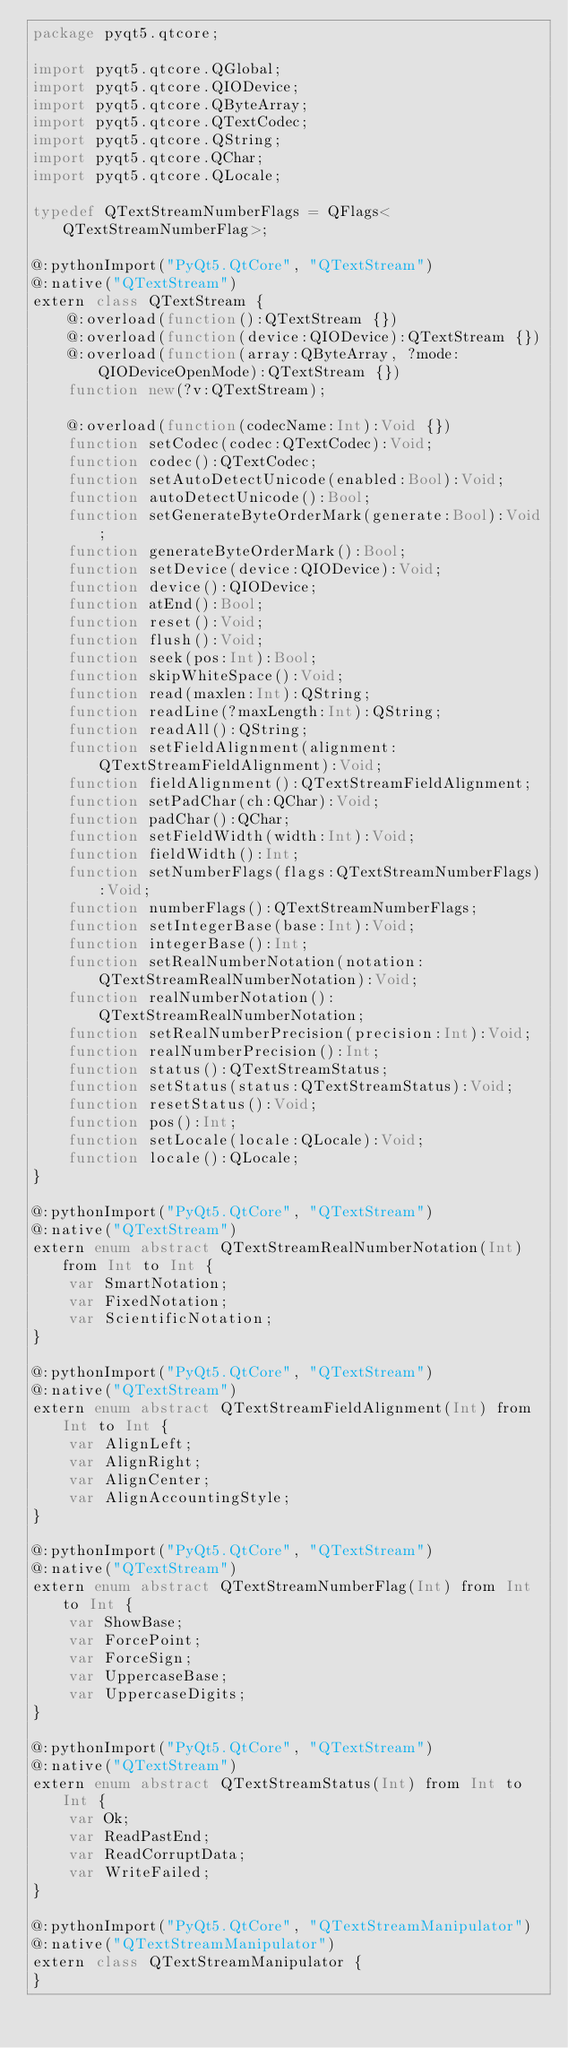<code> <loc_0><loc_0><loc_500><loc_500><_Haxe_>package pyqt5.qtcore;

import pyqt5.qtcore.QGlobal;
import pyqt5.qtcore.QIODevice;
import pyqt5.qtcore.QByteArray;
import pyqt5.qtcore.QTextCodec;
import pyqt5.qtcore.QString;
import pyqt5.qtcore.QChar;
import pyqt5.qtcore.QLocale;

typedef QTextStreamNumberFlags = QFlags<QTextStreamNumberFlag>;

@:pythonImport("PyQt5.QtCore", "QTextStream")
@:native("QTextStream")
extern class QTextStream {
	@:overload(function():QTextStream {})
	@:overload(function(device:QIODevice):QTextStream {})
	@:overload(function(array:QByteArray, ?mode:QIODeviceOpenMode):QTextStream {})
	function new(?v:QTextStream);

	@:overload(function(codecName:Int):Void {})
	function setCodec(codec:QTextCodec):Void;
	function codec():QTextCodec;
	function setAutoDetectUnicode(enabled:Bool):Void;
	function autoDetectUnicode():Bool;
	function setGenerateByteOrderMark(generate:Bool):Void;
	function generateByteOrderMark():Bool;
	function setDevice(device:QIODevice):Void;
	function device():QIODevice;
	function atEnd():Bool;
	function reset():Void;
	function flush():Void;
	function seek(pos:Int):Bool;
	function skipWhiteSpace():Void;
	function read(maxlen:Int):QString;
	function readLine(?maxLength:Int):QString;
	function readAll():QString;
	function setFieldAlignment(alignment:QTextStreamFieldAlignment):Void;
	function fieldAlignment():QTextStreamFieldAlignment;
	function setPadChar(ch:QChar):Void;
	function padChar():QChar;
	function setFieldWidth(width:Int):Void;
	function fieldWidth():Int;
	function setNumberFlags(flags:QTextStreamNumberFlags):Void;
	function numberFlags():QTextStreamNumberFlags;
	function setIntegerBase(base:Int):Void;
	function integerBase():Int;
	function setRealNumberNotation(notation:QTextStreamRealNumberNotation):Void;
	function realNumberNotation():QTextStreamRealNumberNotation;
	function setRealNumberPrecision(precision:Int):Void;
	function realNumberPrecision():Int;
	function status():QTextStreamStatus;
	function setStatus(status:QTextStreamStatus):Void;
	function resetStatus():Void;
	function pos():Int;
	function setLocale(locale:QLocale):Void;
	function locale():QLocale;
}

@:pythonImport("PyQt5.QtCore", "QTextStream")
@:native("QTextStream")
extern enum abstract QTextStreamRealNumberNotation(Int) from Int to Int {
	var SmartNotation;
	var FixedNotation;
	var ScientificNotation;
}

@:pythonImport("PyQt5.QtCore", "QTextStream")
@:native("QTextStream")
extern enum abstract QTextStreamFieldAlignment(Int) from Int to Int {
	var AlignLeft;
	var AlignRight;
	var AlignCenter;
	var AlignAccountingStyle;
}

@:pythonImport("PyQt5.QtCore", "QTextStream")
@:native("QTextStream")
extern enum abstract QTextStreamNumberFlag(Int) from Int to Int {
	var ShowBase;
	var ForcePoint;
	var ForceSign;
	var UppercaseBase;
	var UppercaseDigits;
}

@:pythonImport("PyQt5.QtCore", "QTextStream")
@:native("QTextStream")
extern enum abstract QTextStreamStatus(Int) from Int to Int {
	var Ok;
	var ReadPastEnd;
	var ReadCorruptData;
	var WriteFailed;
}

@:pythonImport("PyQt5.QtCore", "QTextStreamManipulator")
@:native("QTextStreamManipulator")
extern class QTextStreamManipulator {
}

</code> 